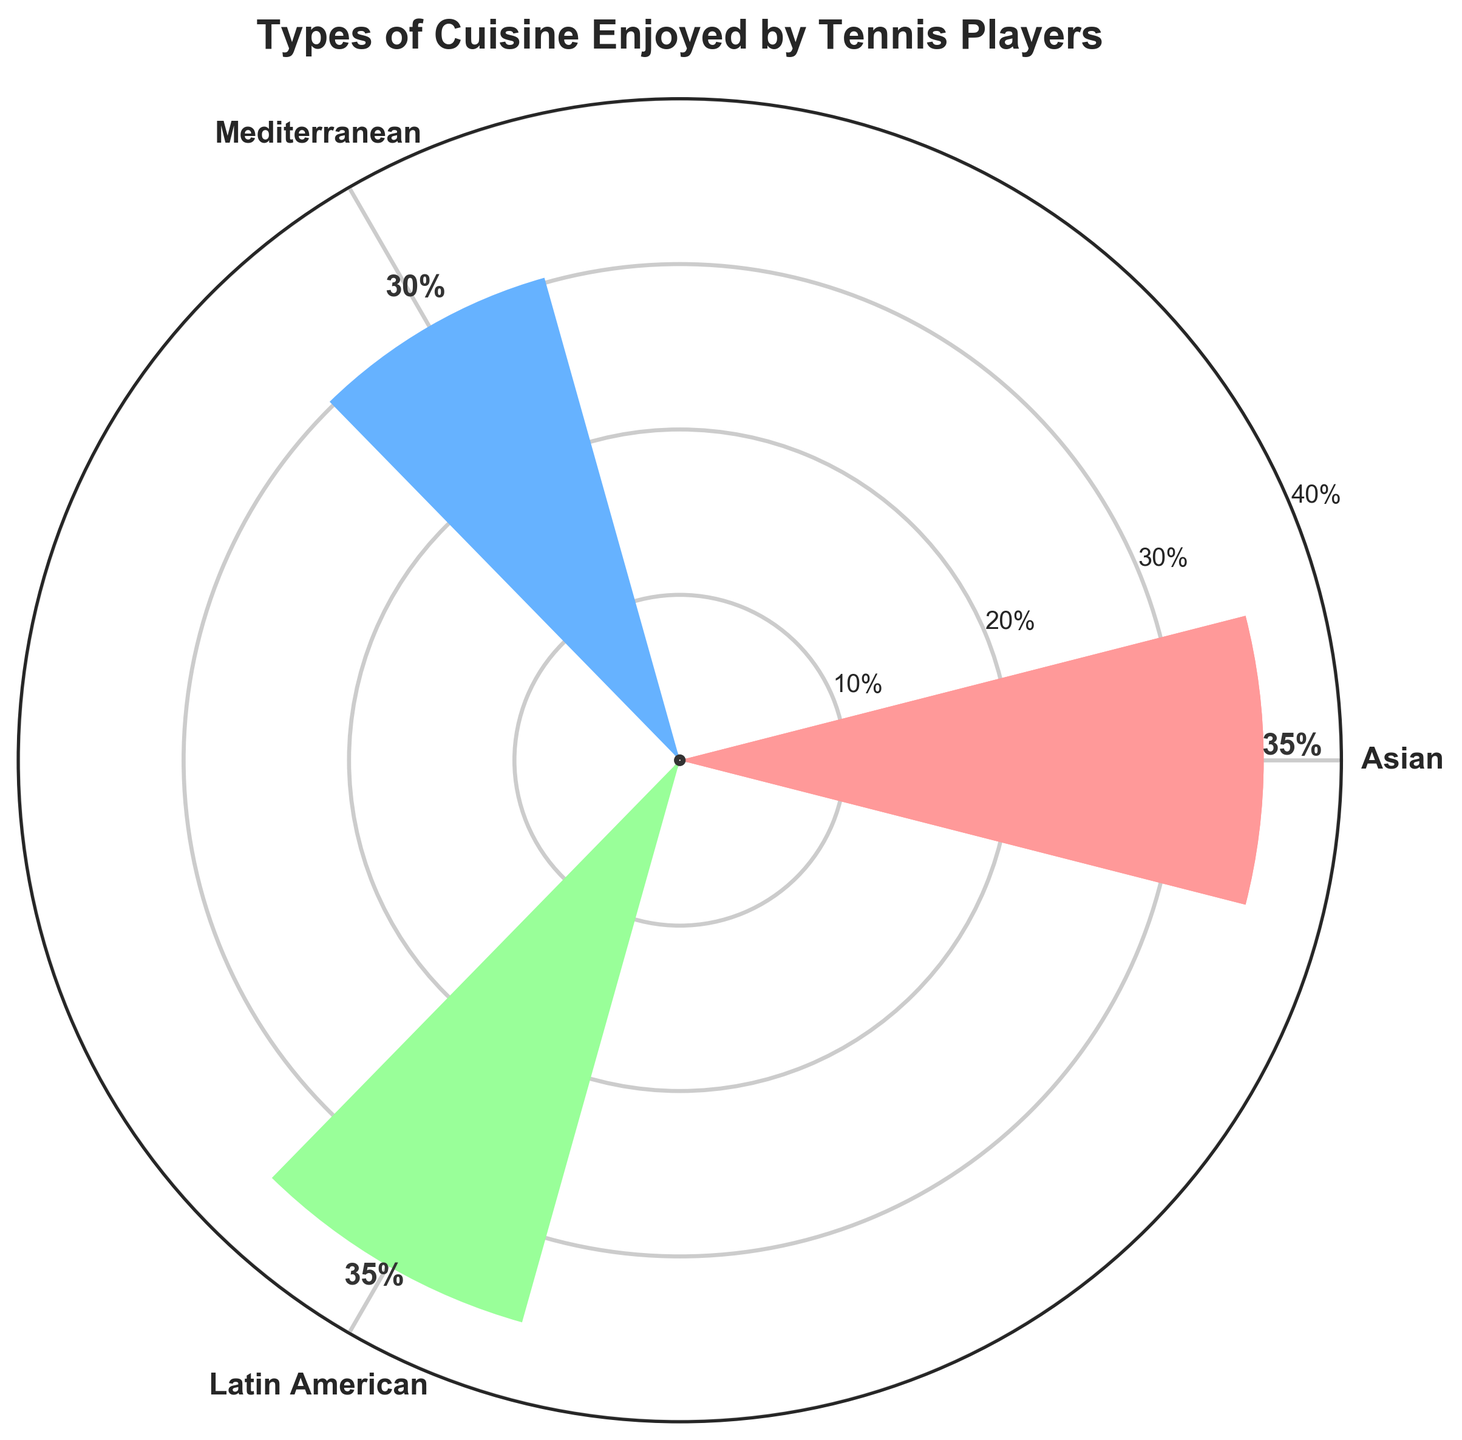What's the title of the chart? The title is located at the top of the chart and is usually in bold and larger font size compared to other elements.
Answer: Types of Cuisine Enjoyed by Tennis Players How many types of cuisines are represented in the figure? The data shows three different cuisine types plotted radially around the circle.
Answer: 3 Which types of cuisine have the highest percentage? By comparing the height of the bars, both Asian and Latin American cuisines have the highest bars.
Answer: Asian and Latin American What percentage of Mediterranean cuisine is enjoyed by tennis players? The label above the bar representing Mediterranean cuisine reads 30%.
Answer: 30% What is the difference between the percentage of Asian and Mediterranean cuisines enjoyed by tennis players? Subtract the percentage of Mediterranean cuisine (30%) from the percentage of Asian cuisine (35%).
Answer: 5% What percentage of tennis players enjoy cuisines other than Mediterranean? Sum the percentages of Asian and Latin American cuisines (35% + 35%).
Answer: 70% If tennis players’ preferences were evenly distributed, what would be the percentage for each cuisine type? Divide 100% by the number of cuisine types (3).
Answer: 33.33% Between which cuisines is there an equal percentage of enjoyment? The heights of the bars for both Asian and Latin American cuisines are the same at 35%.
Answer: Asian and Latin American What is the average percentage of all the cuisines enjoyed by tennis players? Sum the percentages (35 + 30 + 35) and divide by the number of cuisines (3).
Answer: 33.33% How does the representation of Mediterranean cuisine compare to the average enjoyment percentage of all cuisines? The average percentage was calculated as 33.33%. The percentage for Mediterranean cuisine is 30%, which is 3.33% less than the average.
Answer: 3.33% less 